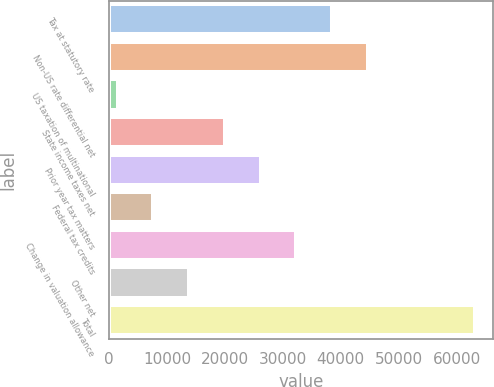Convert chart to OTSL. <chart><loc_0><loc_0><loc_500><loc_500><bar_chart><fcel>Tax at statutory rate<fcel>Non-US rate differential net<fcel>US taxation of multinational<fcel>State income taxes net<fcel>Prior year tax matters<fcel>Federal tax credits<fcel>Change in valuation allowance<fcel>Other net<fcel>Total<nl><fcel>38504<fcel>44673.5<fcel>1487<fcel>19995.5<fcel>26165<fcel>7656.5<fcel>32334.5<fcel>13826<fcel>63182<nl></chart> 